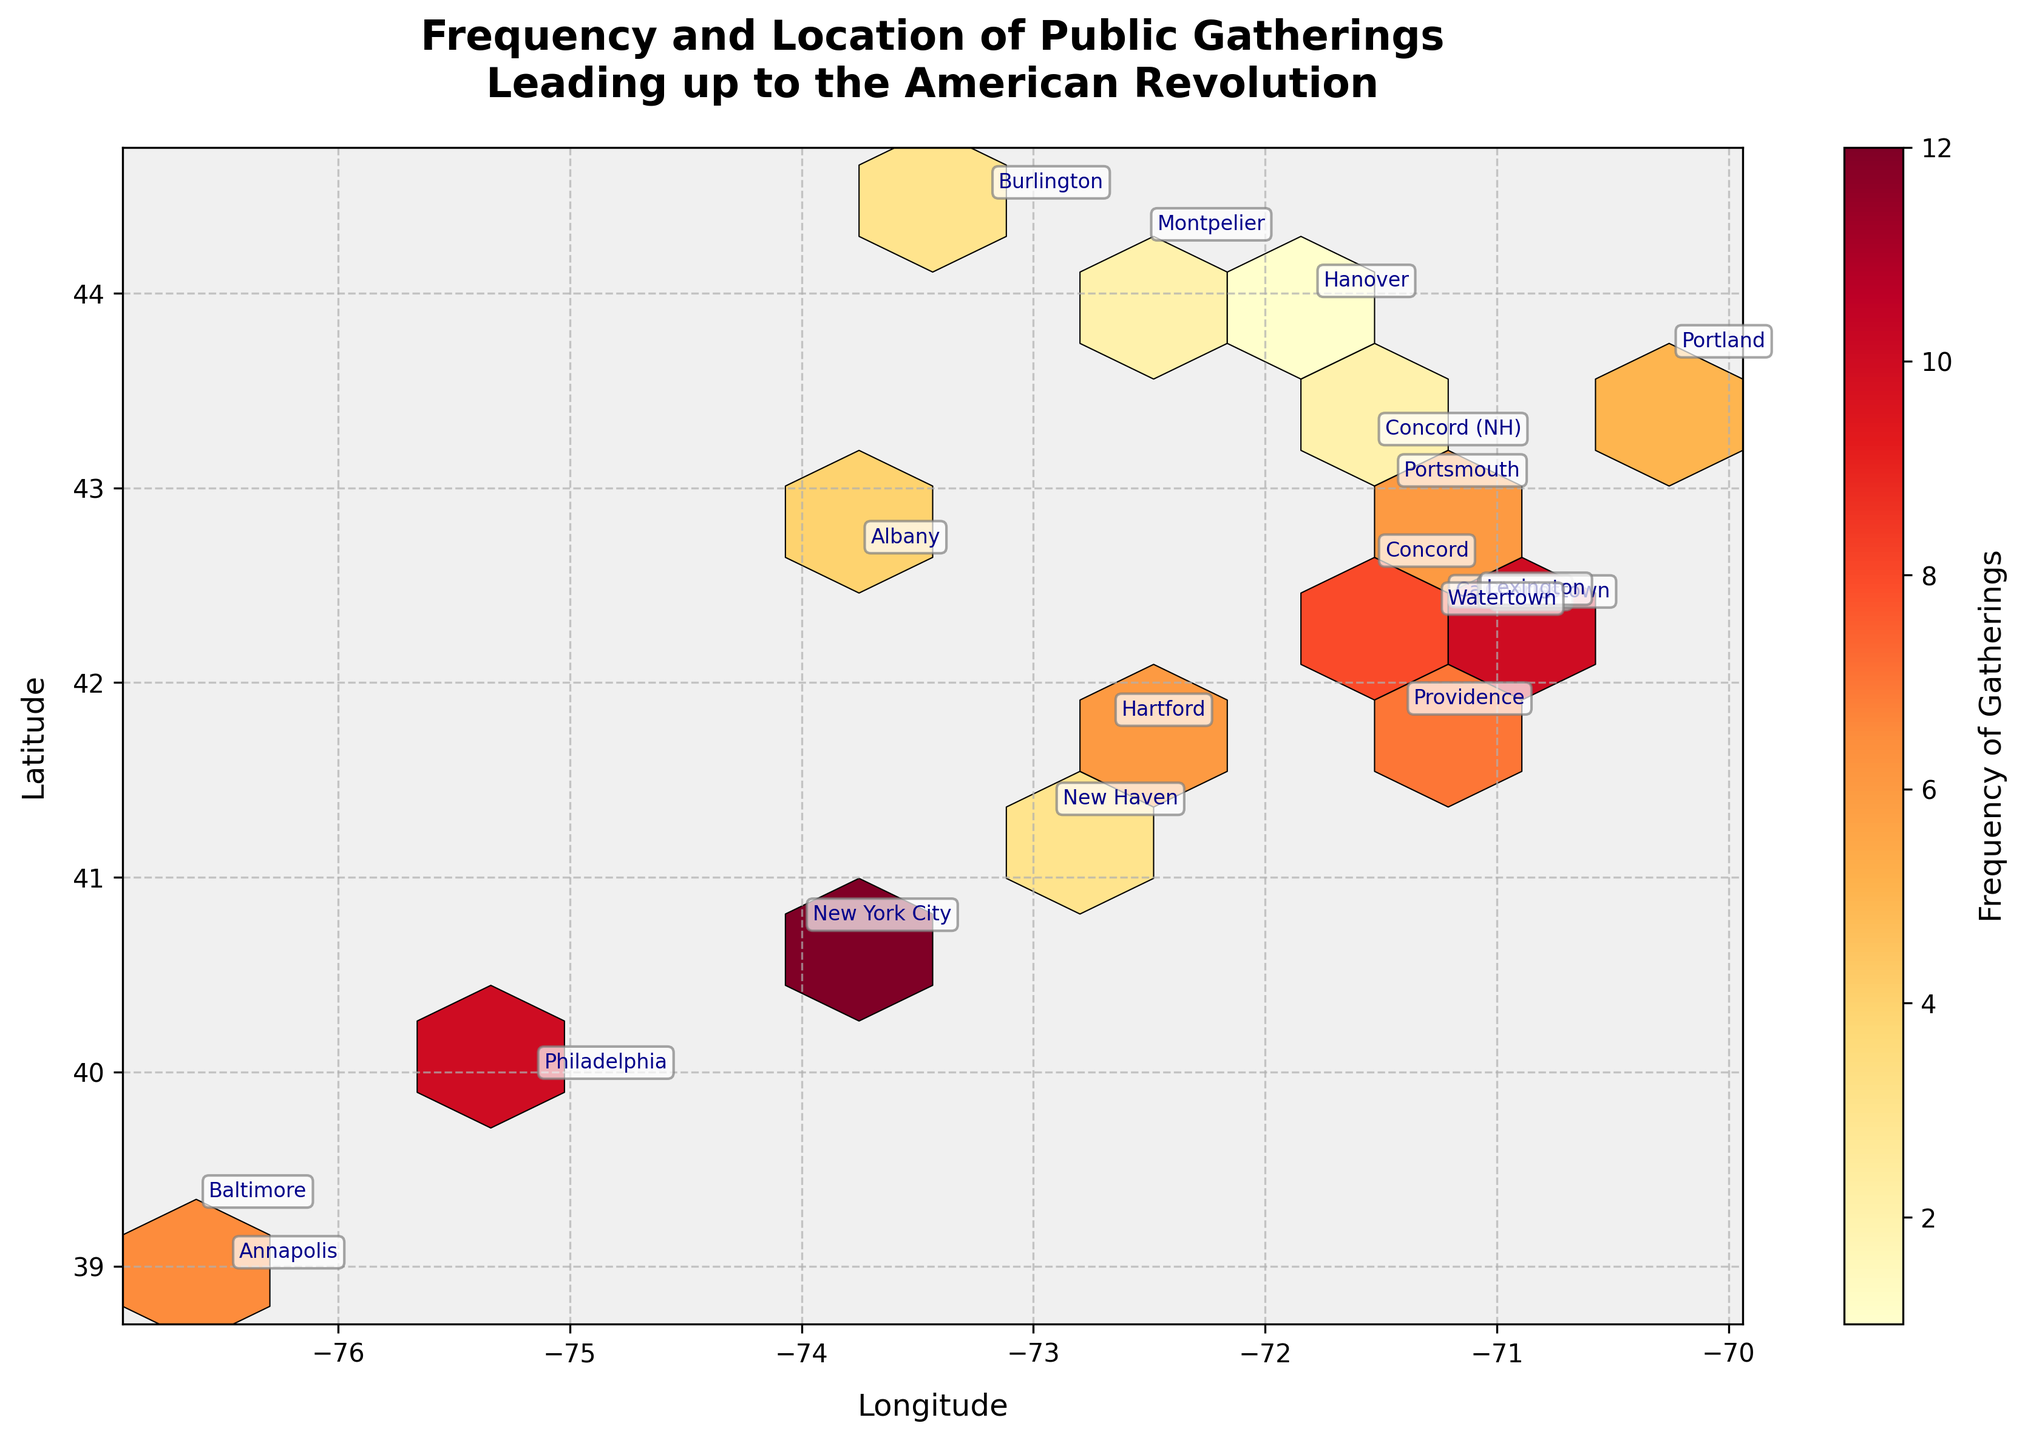What is the title of the plot? The title is located at the top of the plot and provides an overview of the figure’s subject matter. It reads "Frequency and Location of Public Gatherings Leading up to the American Revolution".
Answer: Frequency and Location of Public Gatherings Leading up to the American Revolution How many cities are annotated on the plot? The annotations represent each city involved in the data. By counting the labels, we see there are 20 cities annotated on the plot.
Answer: 20 Which city had the highest frequency of public gatherings? By looking at the bins with the highest density of color (dark red), and checking the annotations, we can identify that Boston has the highest frequency, which is 15.
Answer: Boston Compare the frequency of public gatherings in Boston and New York City. Which had more gatherings and by how many? Looking at the hexbin color and annotations, we see Boston had 15 gatherings and New York City had 12 gatherings. Thus, Boston had 3 more gatherings than New York City.
Answer: Boston had 3 more gatherings What are the longitude and latitude ranges displayed in the plot? The x-axis represents the longitude, and the y-axis represents the latitude. By checking the axis limits, we see the longitude ranges from approximately -77 to -70, and the latitude ranges from approximately 38 to 44.
Answer: Longitude: -77 to -70; Latitude: 38 to 44 Which two cities had the same frequency of public gatherings? We need to look for hexagons with the same color indicating the same frequency, cross-referenced by annotations. Cambridge and Charlestown both had a frequency of 8.
Answer: Cambridge and Charlestown What is the average frequency of public gatherings across all the annotated cities? Summing the frequencies (15+12+10+8+7+6+9+5+4+11+8+6+3+5+7+4+3+2+1+2=129) and dividing by the number of cities (20), the average frequency is 129/20 = 6.45.
Answer: 6.45 Based on the hexbin plot, which region (north or south) had a higher concentration of public gatherings? By observing the density of the hexagons filled with colors, it is noticeable that the northern region has a higher concentration of public gatherings since the majority of dense hexabins are located near the top of the plot.
Answer: North 